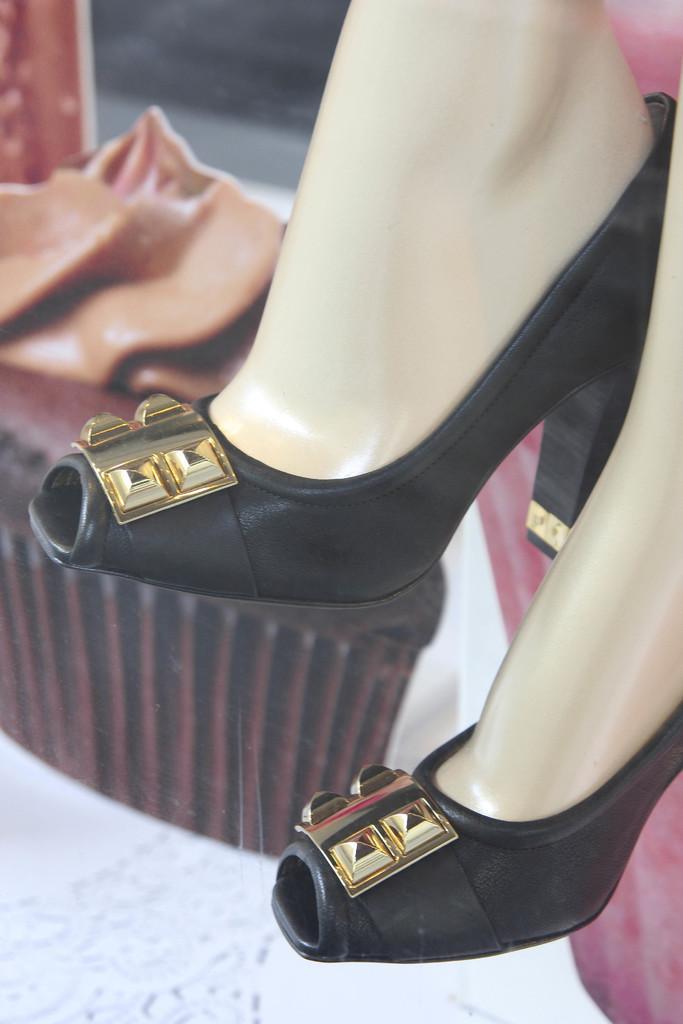In one or two sentences, can you explain what this image depicts? This picture shows black colored women footwear. 